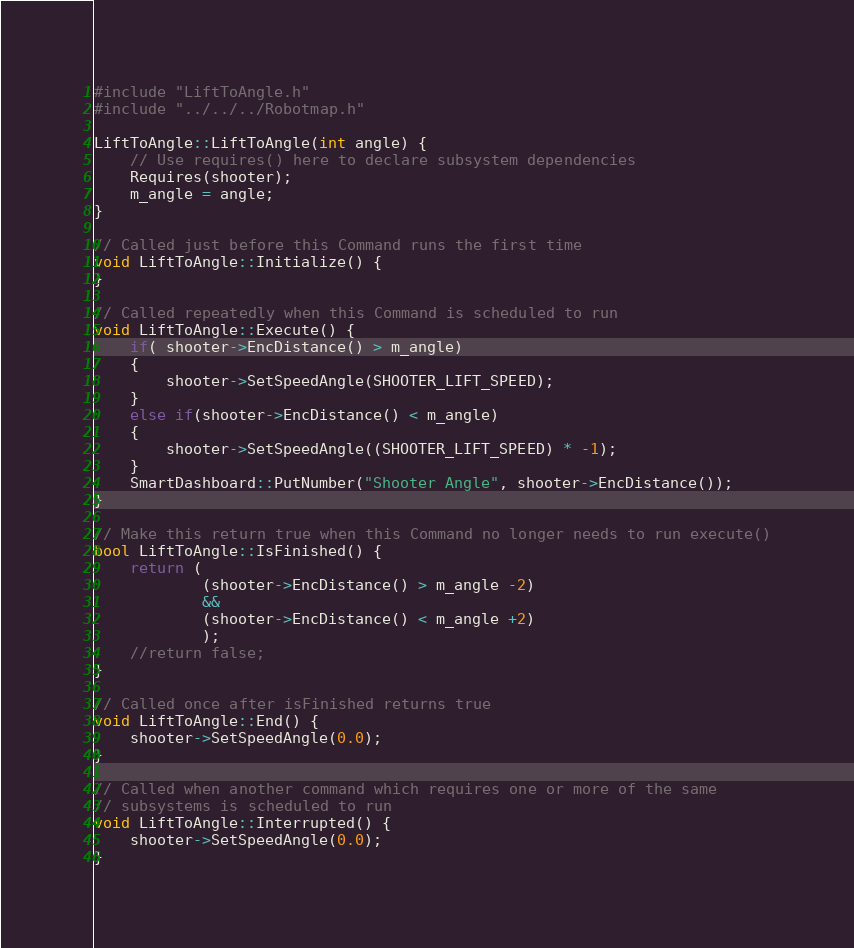Convert code to text. <code><loc_0><loc_0><loc_500><loc_500><_C++_>#include "LiftToAngle.h"
#include "../../../Robotmap.h"

LiftToAngle::LiftToAngle(int angle) {
	// Use requires() here to declare subsystem dependencies
	Requires(shooter);
	m_angle = angle;
}

// Called just before this Command runs the first time
void LiftToAngle::Initialize() {
}

// Called repeatedly when this Command is scheduled to run
void LiftToAngle::Execute() {
	if( shooter->EncDistance() > m_angle)
	{
		shooter->SetSpeedAngle(SHOOTER_LIFT_SPEED);
	}
	else if(shooter->EncDistance() < m_angle)
	{
		shooter->SetSpeedAngle((SHOOTER_LIFT_SPEED) * -1);
	}
	SmartDashboard::PutNumber("Shooter Angle", shooter->EncDistance());
}

// Make this return true when this Command no longer needs to run execute()
bool LiftToAngle::IsFinished() {
	return (
			(shooter->EncDistance() > m_angle -2)
			&&
			(shooter->EncDistance() < m_angle +2)
			);
	//return false;
}

// Called once after isFinished returns true
void LiftToAngle::End() {
	shooter->SetSpeedAngle(0.0);
}

// Called when another command which requires one or more of the same
// subsystems is scheduled to run
void LiftToAngle::Interrupted() {
	shooter->SetSpeedAngle(0.0);
}
</code> 